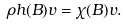Convert formula to latex. <formula><loc_0><loc_0><loc_500><loc_500>\rho h ( B ) v = \chi ( B ) v .</formula> 